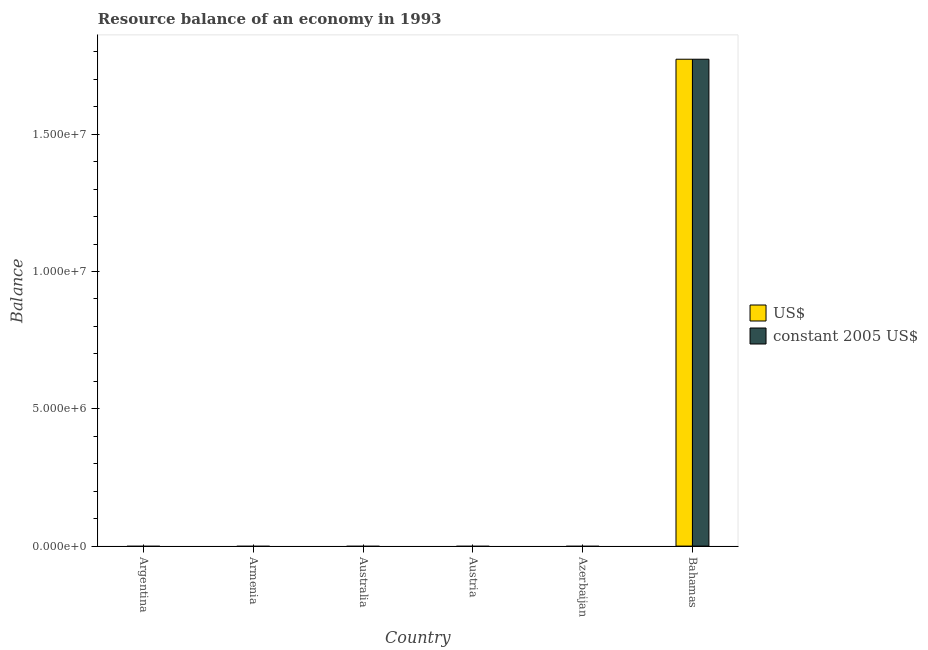How many different coloured bars are there?
Give a very brief answer. 2. Are the number of bars per tick equal to the number of legend labels?
Offer a very short reply. No. How many bars are there on the 6th tick from the left?
Offer a terse response. 2. What is the label of the 6th group of bars from the left?
Your response must be concise. Bahamas. Across all countries, what is the maximum resource balance in us$?
Keep it short and to the point. 1.77e+07. Across all countries, what is the minimum resource balance in us$?
Keep it short and to the point. 0. In which country was the resource balance in us$ maximum?
Make the answer very short. Bahamas. What is the total resource balance in us$ in the graph?
Give a very brief answer. 1.77e+07. What is the difference between the resource balance in constant us$ in Australia and the resource balance in us$ in Bahamas?
Offer a very short reply. -1.77e+07. What is the average resource balance in us$ per country?
Provide a succinct answer. 2.96e+06. What is the difference between the resource balance in constant us$ and resource balance in us$ in Bahamas?
Your response must be concise. 0. In how many countries, is the resource balance in constant us$ greater than 8000000 units?
Provide a short and direct response. 1. What is the difference between the highest and the lowest resource balance in us$?
Your response must be concise. 1.77e+07. In how many countries, is the resource balance in us$ greater than the average resource balance in us$ taken over all countries?
Your answer should be compact. 1. How many countries are there in the graph?
Provide a succinct answer. 6. Are the values on the major ticks of Y-axis written in scientific E-notation?
Offer a terse response. Yes. Does the graph contain any zero values?
Your answer should be compact. Yes. Does the graph contain grids?
Keep it short and to the point. No. Where does the legend appear in the graph?
Provide a succinct answer. Center right. How are the legend labels stacked?
Keep it short and to the point. Vertical. What is the title of the graph?
Offer a very short reply. Resource balance of an economy in 1993. What is the label or title of the X-axis?
Offer a terse response. Country. What is the label or title of the Y-axis?
Your answer should be very brief. Balance. What is the Balance in US$ in Argentina?
Offer a terse response. 0. What is the Balance in US$ in Armenia?
Keep it short and to the point. 0. What is the Balance in constant 2005 US$ in Armenia?
Provide a short and direct response. 0. What is the Balance in US$ in Azerbaijan?
Make the answer very short. 0. What is the Balance in US$ in Bahamas?
Offer a terse response. 1.77e+07. What is the Balance of constant 2005 US$ in Bahamas?
Provide a short and direct response. 1.77e+07. Across all countries, what is the maximum Balance of US$?
Your answer should be compact. 1.77e+07. Across all countries, what is the maximum Balance in constant 2005 US$?
Provide a succinct answer. 1.77e+07. Across all countries, what is the minimum Balance of US$?
Offer a terse response. 0. What is the total Balance in US$ in the graph?
Offer a very short reply. 1.77e+07. What is the total Balance in constant 2005 US$ in the graph?
Your response must be concise. 1.77e+07. What is the average Balance in US$ per country?
Make the answer very short. 2.96e+06. What is the average Balance in constant 2005 US$ per country?
Give a very brief answer. 2.96e+06. What is the difference between the highest and the lowest Balance in US$?
Give a very brief answer. 1.77e+07. What is the difference between the highest and the lowest Balance in constant 2005 US$?
Make the answer very short. 1.77e+07. 